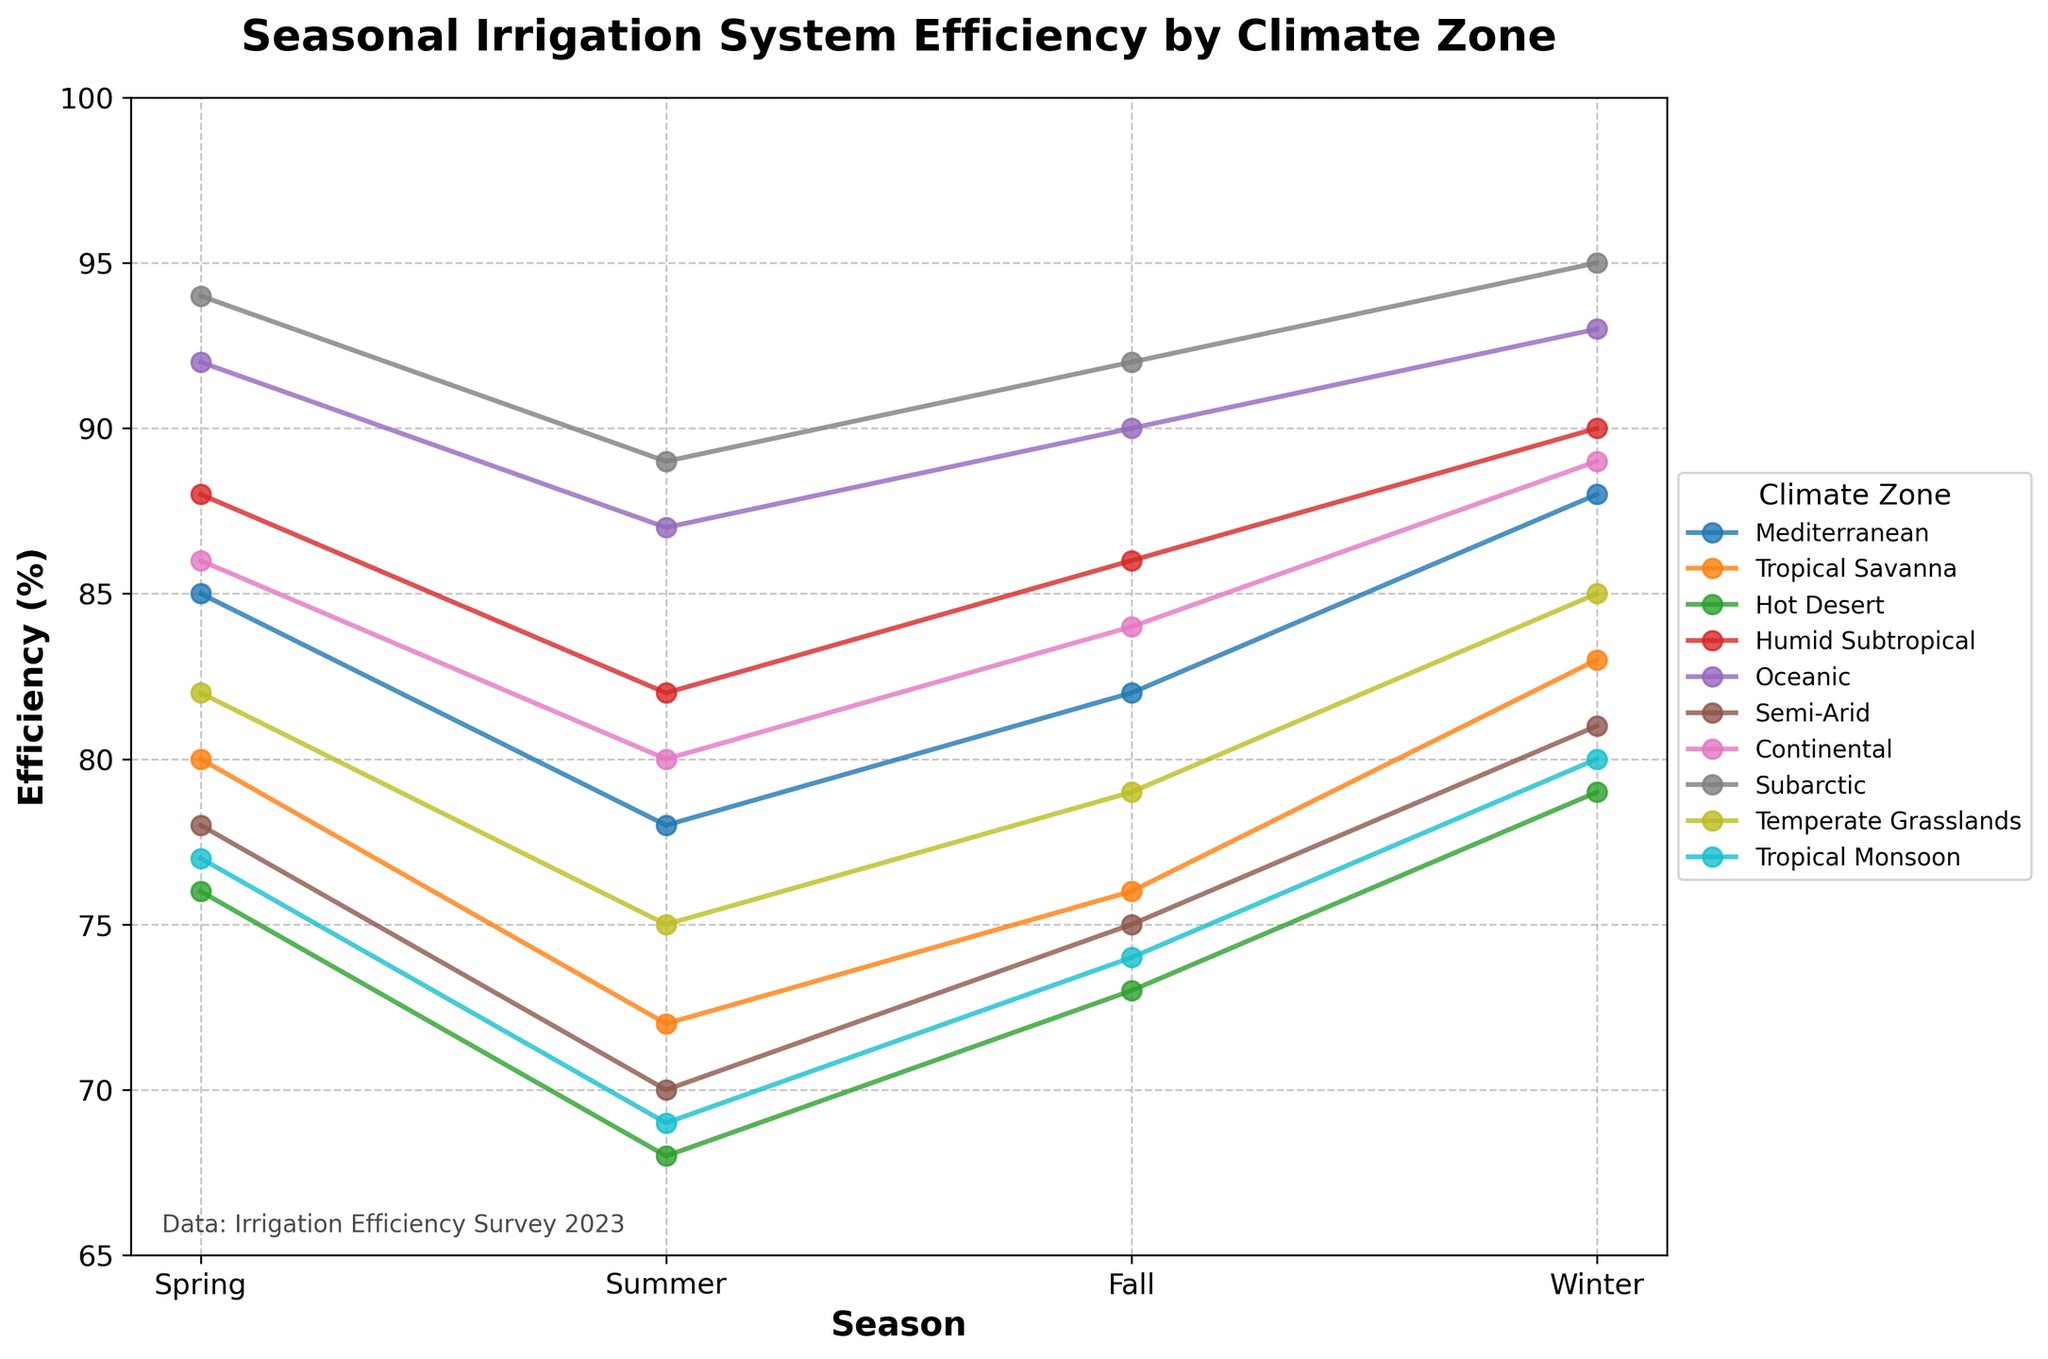Which climate zone has the highest irrigation efficiency in winter? From the plot, identify the line peaking highest in the winter season. Subarctic zone shows the highest value in winter.
Answer: Subarctic Which season shows the lowest irrigation efficiency for Tropical Savanna? By comparing the efficiency values of Tropical Savanna across all seasons, the value is lowest in summer.
Answer: Summer What is the average irrigation efficiency for the Oceanic climate zone across all seasons? Sum the efficiency percentages for Oceanic climate (92 + 87 + 90 + 93), then divide by 4. The average is (362 / 4) = 90.5%.
Answer: 90.5% How much higher is the winter efficiency in Humid Subtropical compared to Hot Desert? Subtract Hot Desert's winter efficiency from Humid Subtropical's winter efficiency: (90 - 79) = 11%.
Answer: 11% Which climate zone shows the biggest seasonal variation in irrigation efficiency, and what is this variation? Calculate the difference between the highest and lowest efficiency for each zone. For Tropical Monsoon, the values show the biggest variation from winter (80) to summer (69), making the variation (80 - 69) = 11%.
Answer: Tropical Monsoon, 11% Is the fall efficiency for Continental higher or lower than the spring efficiency for Semi-Arid? Compare the fall efficiency (84%) of Continental with the spring efficiency (78%) of Semi-Arid.
Answer: Higher What is the combined efficiency in summer and fall for the Mediterranean climate zone? Add the summer and fall efficiencies for Mediterranean (78 + 82) = 160%.
Answer: 160% Does any climate zone exhibit a decrease in efficiency from fall to winter? Examine each climate zone's efficiency values between fall and winter. All zones listed show an increase from fall to winter.
Answer: No Which climate zones have an efficiency greater than 85% in both spring and fall? Compare the spring and fall efficiencies for all zones. Humid Subtropical (88, 86) and Subarctic (94, 92) show values above 85% in both seasons.
Answer: Humid Subtropical, Subarctic 